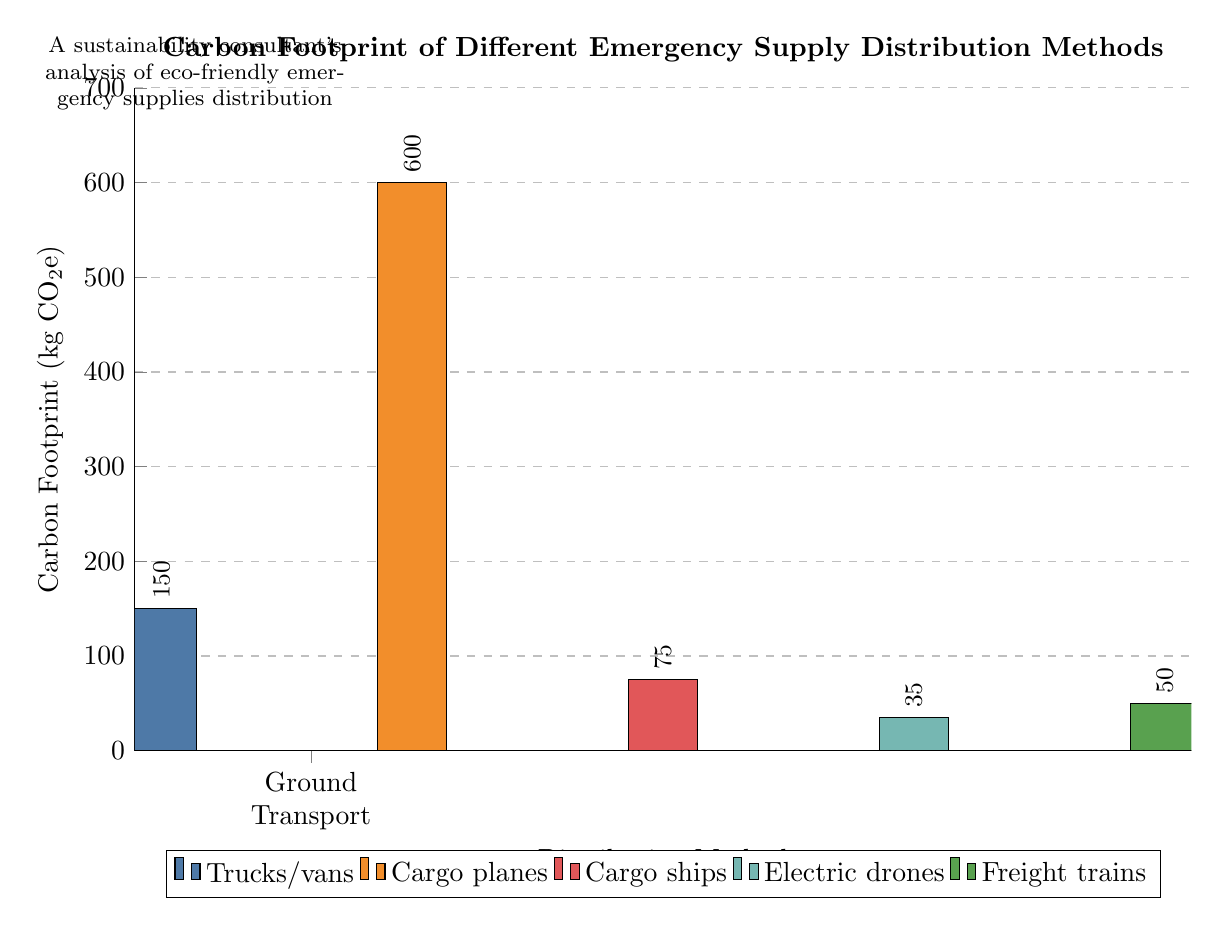What is the carbon footprint of ground transport? The bar representing ground transport reaches a value of 150 kg CO2e on the y-axis, indicating the carbon footprint for this method.
Answer: 150 kg CO2e Which distribution method has the highest carbon footprint? The bar for air transport extends to 600 kg CO2e, which is higher than any other method in the diagram.
Answer: Air transport How many distribution methods are represented in the diagram? There are five distribution methods shown in the x-axis: ground transport, air transport, maritime transport, drone delivery, and rail transport.
Answer: 5 What is the carbon footprint of drone delivery? The height of the bar for drone delivery corresponds to a value of 35 kg CO2e, as indicated on the y-axis.
Answer: 35 kg CO2e Which two methods have a carbon footprint of less than 100 kg CO2e? By examining the bars, both maritime transport and drone delivery have carbon footprints of 75 kg CO2e and 35 kg CO2e, respectively, which are both below 100.
Answer: Maritime transport and drone delivery What is the total carbon footprint of all distribution methods combined? Calculating the sum of the carbon footprints: 150 + 600 + 75 + 35 + 50 = 910 kg CO2e gives us the total carbon footprint across all methods.
Answer: 910 kg CO2e Which distribution method is represented by the orange bar? The orange bar corresponds to the air transport method, which has a carbon footprint of 600 kg CO2e indicated by its color and position in the chart.
Answer: Air transport Which distribution method has the lowest carbon footprint? The green bar for electric drones indicates the lowest carbon footprint at 35 kg CO2e when compared against the other methods.
Answer: Electric drones What does the dashed grid represent in the diagram? The dashed grid lines in the background are used to help visually quantify the carbon footprint values along the y-axis and create a clearer representation of data.
Answer: Visual guidance for values 